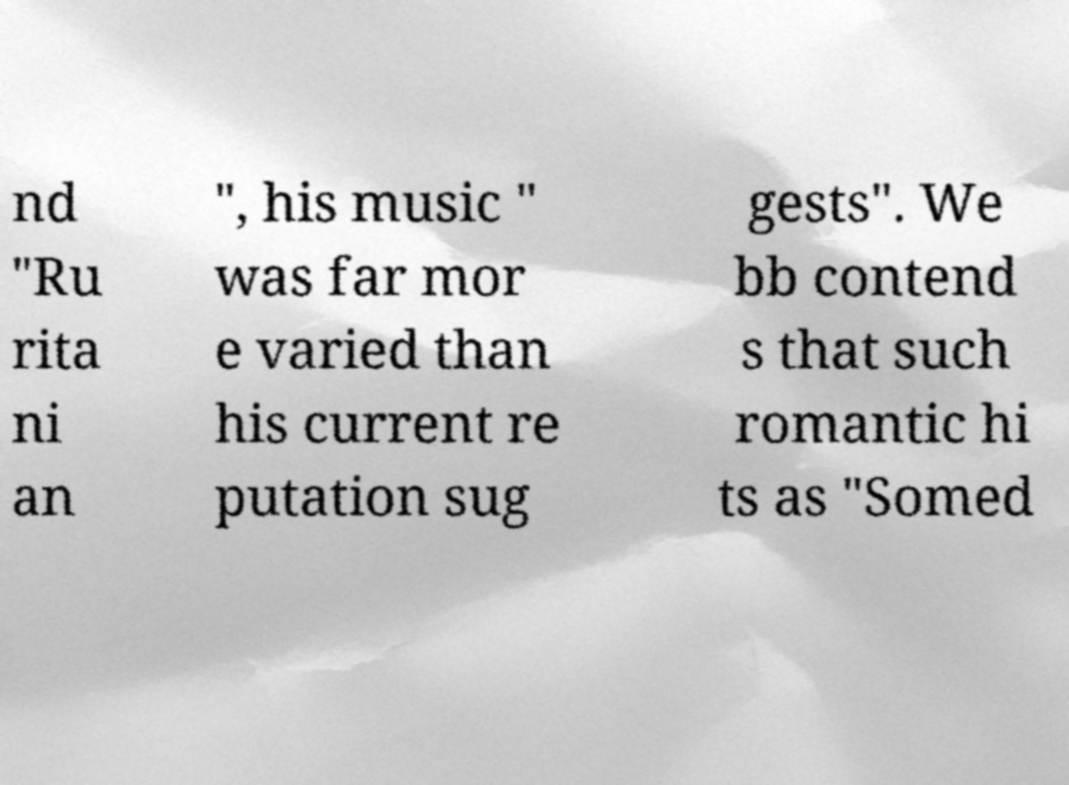Could you extract and type out the text from this image? nd "Ru rita ni an ", his music " was far mor e varied than his current re putation sug gests". We bb contend s that such romantic hi ts as "Somed 